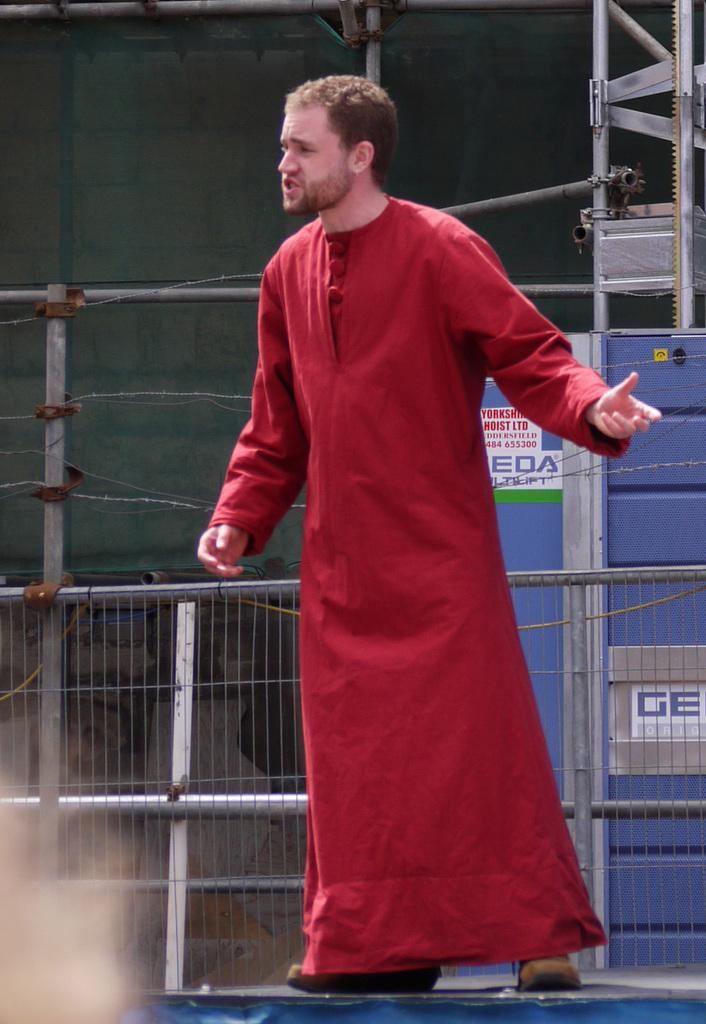What is the main subject of the image? There is a person standing in the image. What is the person doing in the image? The person is speaking. What is the person wearing in the image? The person is wearing a red-colored dress. What can be seen in the background of the image? There is a fencing present in the image. Are there any leather items visible in the image? There is no mention of leather items in the provided facts, so it cannot be determined if any are present in the image. 